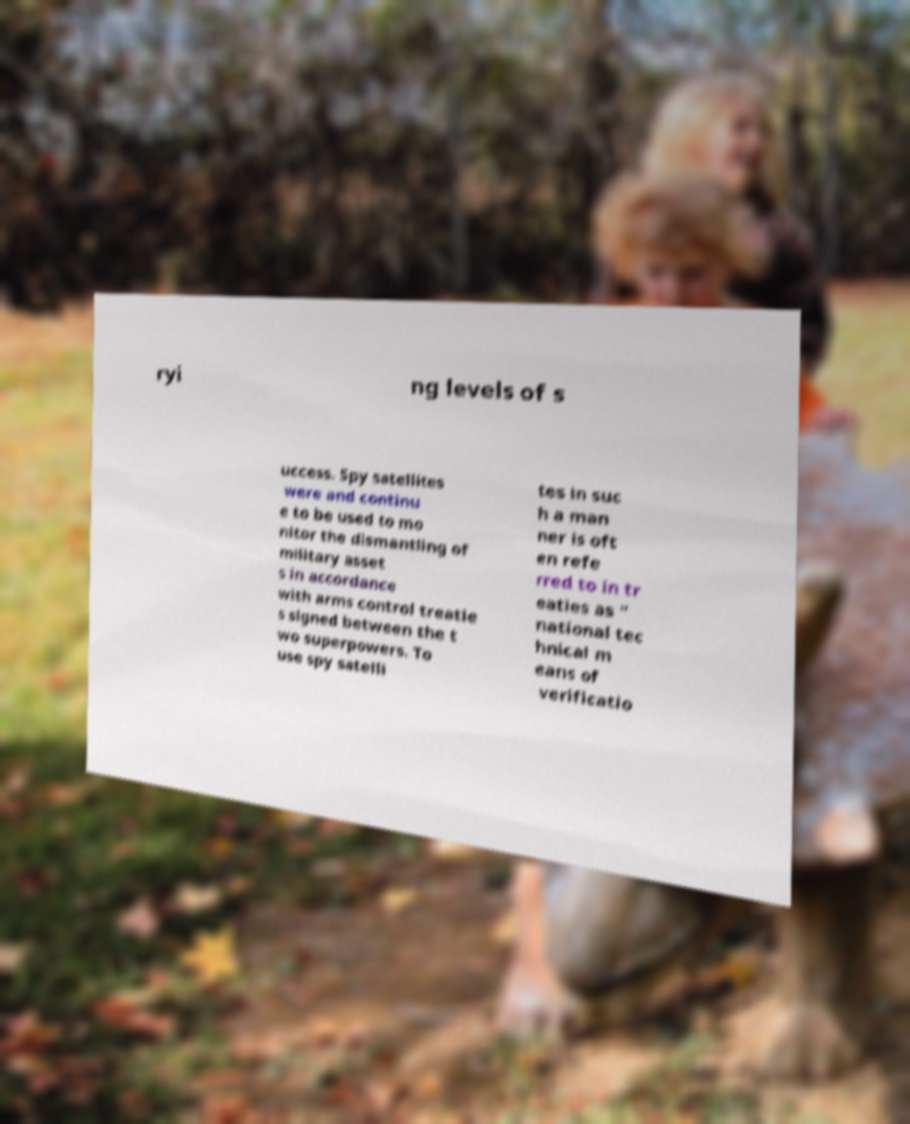Please read and relay the text visible in this image. What does it say? ryi ng levels of s uccess. Spy satellites were and continu e to be used to mo nitor the dismantling of military asset s in accordance with arms control treatie s signed between the t wo superpowers. To use spy satelli tes in suc h a man ner is oft en refe rred to in tr eaties as " national tec hnical m eans of verificatio 